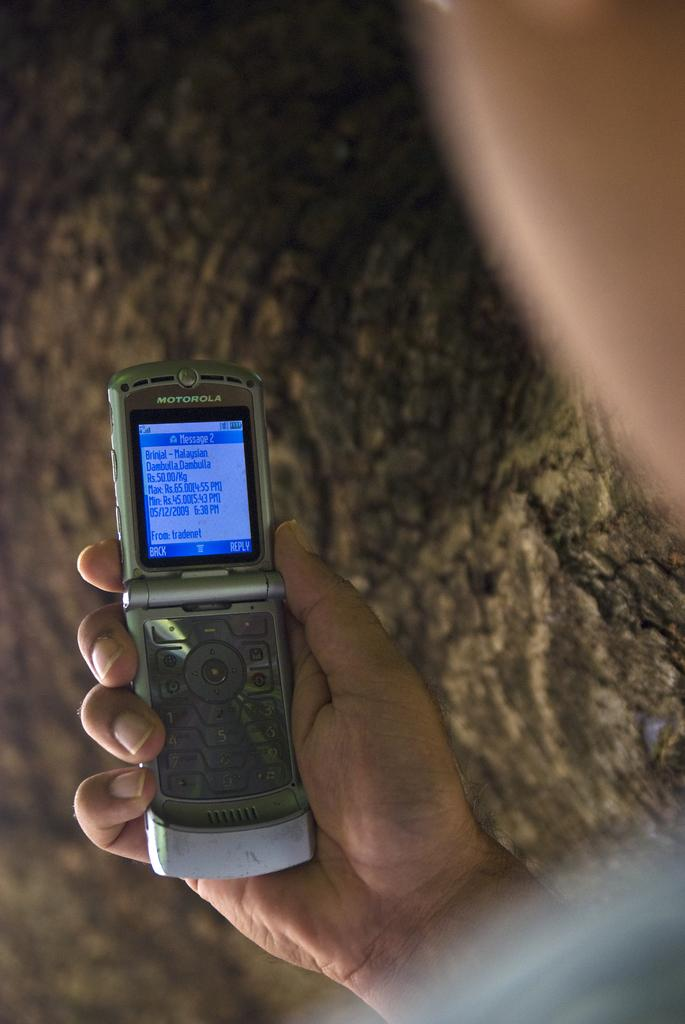<image>
Relay a brief, clear account of the picture shown. Someone holds open a flip phone that shows 2 Messages on it. 